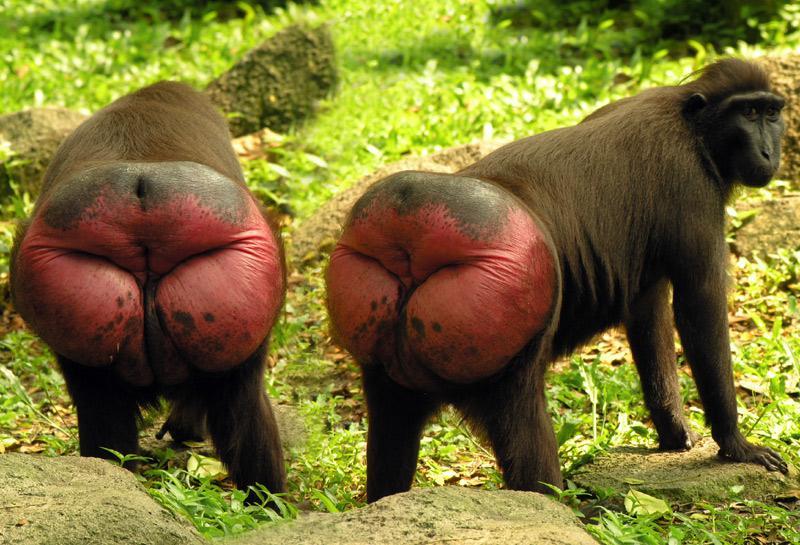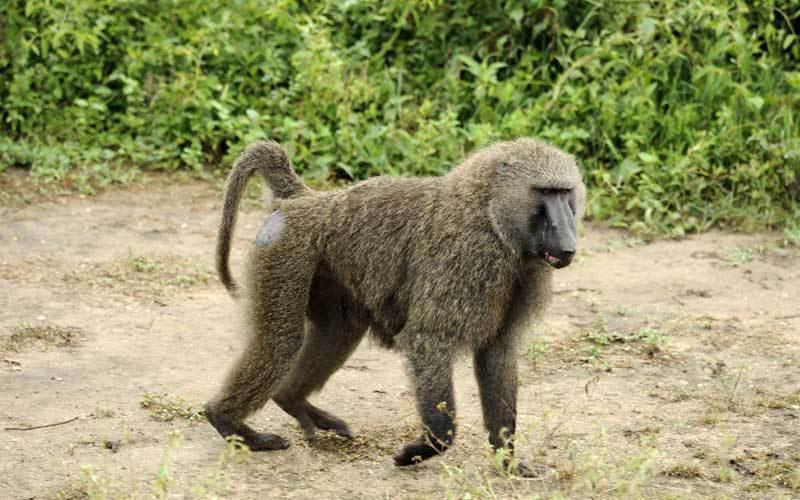The first image is the image on the left, the second image is the image on the right. Analyze the images presented: Is the assertion "An image shows two rear-facing baboons." valid? Answer yes or no. Yes. 